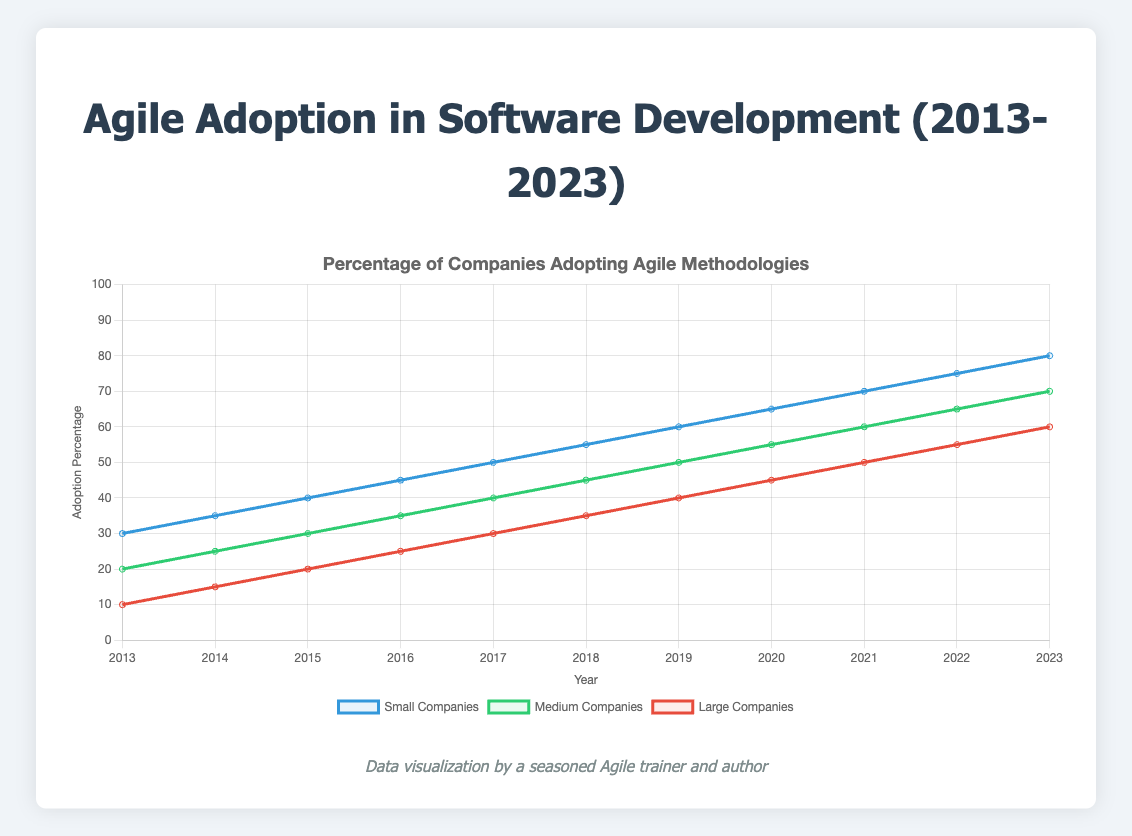What is the adoption percentage of Agile methodologies for small companies in 2023? Refer to the line chart and locate the data point for small companies in 2023. The y-value at this point represents the adoption percentage.
Answer: 80% Which company size saw the highest increase in Agile adoption from 2013 to 2023? Compare the final adoption percentages in 2023 with those in 2013 for each company size. Subtract the 2013 value from the 2023 value to find the increases: Small companies (80-30), Medium companies (70-20), Large companies (60-10).
Answer: Small companies Between which years did medium companies see the largest increase in Agile adoption? Examine the slopes of the line representing medium companies. Identify the steepest section by comparing the difference in y-values between successive years: 2018 to 2019 (45 to 50) or 2022 to 2023 (65 to 70). Both increments are equal but selecting any one year range is viable.
Answer: 2018 to 2019 or 2022 to 2023 What is the total percentage increase in Agile adoption across all company sizes from 2013 to 2023? Compute the overall increases for each company size (Small: 80-30, Medium: 70-20, Large: 60-10). Sum these increases: (50 + 50 + 50).
Answer: 150% Which company size had the least adoption of Agile methodologies in 2017? Locate the data points for all three company sizes in 2017. Compare the y-values and identify the smallest: Small companies (50), Medium companies (40), Large companies (30).
Answer: Large companies How did the adoption trend for large companies change over the period from 2013 to 2023? Visually analyze the slope of the line for large companies from 2013 to 2023. Identify if the line consistently increases, and by how much each year. The slope is consistently positive, representing a gradual increase each year.
Answer: Consistent increase Calculate the average adoption percentage for medium companies between 2013 and 2023. Sum the adoption percentages from 2013 to 2023 for medium companies (20 + 25 + 30 + 35 + 40 + 45 + 50 + 55 + 60 + 65 + 70), total this sum (495), divide by the number of years (11).
Answer: 45% During which year did small companies achieve over twice the adoption rate of large companies for the first time? Determine the years where the adoption percentage of small companies is more than twice that of large companies. Perform the calculation for each year until the condition is met: 2016, where (45 > 2*25).
Answer: 2016 